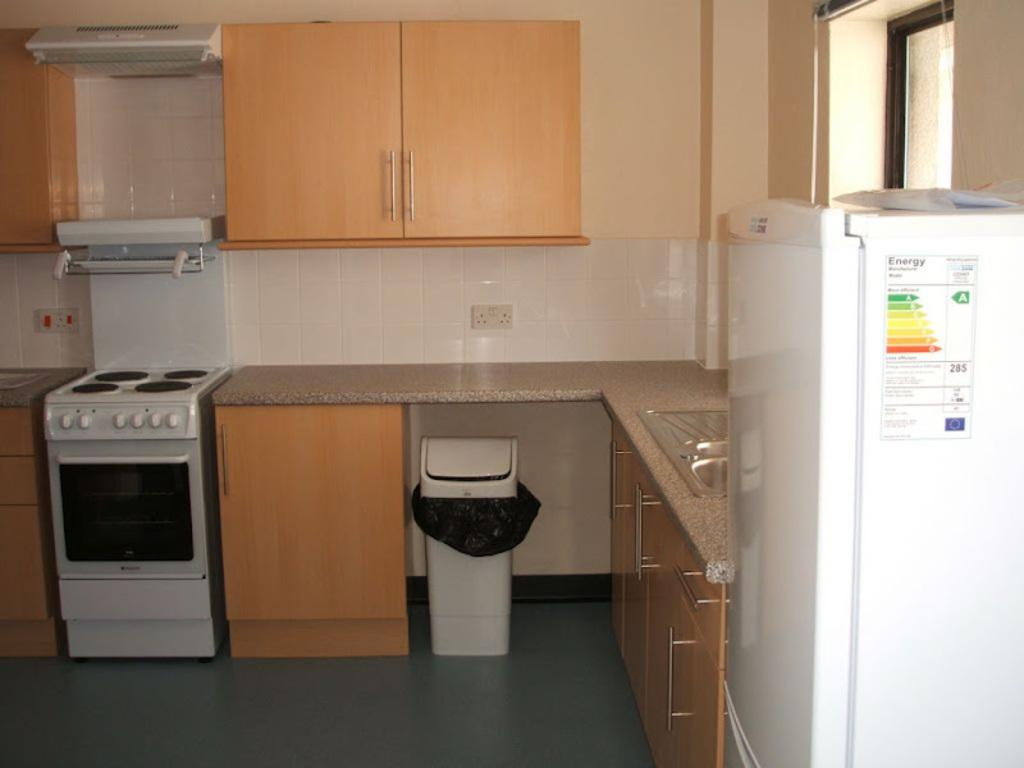<image>
Relay a brief, clear account of the picture shown. An empty kitchen with a stove and refrigerator with a page titled energy pinned to it. 